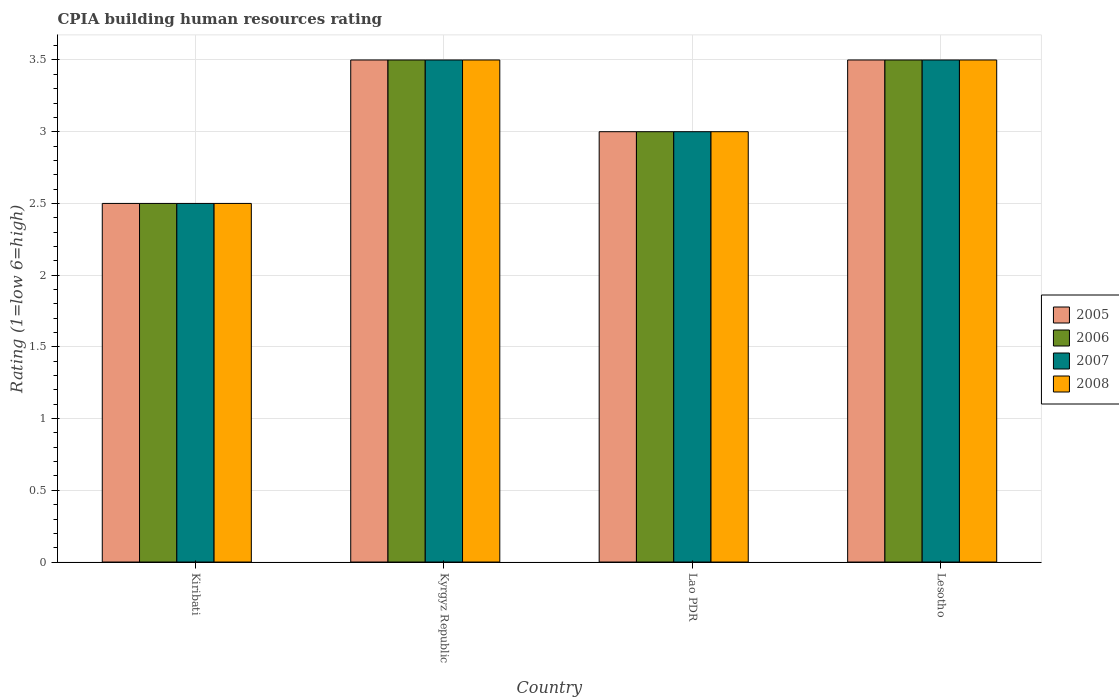Are the number of bars per tick equal to the number of legend labels?
Your answer should be very brief. Yes. Are the number of bars on each tick of the X-axis equal?
Give a very brief answer. Yes. How many bars are there on the 2nd tick from the left?
Ensure brevity in your answer.  4. What is the label of the 2nd group of bars from the left?
Provide a succinct answer. Kyrgyz Republic. In how many cases, is the number of bars for a given country not equal to the number of legend labels?
Give a very brief answer. 0. Across all countries, what is the maximum CPIA rating in 2007?
Offer a terse response. 3.5. In which country was the CPIA rating in 2008 maximum?
Make the answer very short. Kyrgyz Republic. In which country was the CPIA rating in 2006 minimum?
Your answer should be very brief. Kiribati. What is the total CPIA rating in 2008 in the graph?
Offer a terse response. 12.5. What is the average CPIA rating in 2007 per country?
Give a very brief answer. 3.12. What is the ratio of the CPIA rating in 2007 in Kiribati to that in Lao PDR?
Provide a short and direct response. 0.83. Is the difference between the CPIA rating in 2005 in Kiribati and Kyrgyz Republic greater than the difference between the CPIA rating in 2007 in Kiribati and Kyrgyz Republic?
Your answer should be very brief. No. What is the difference between the highest and the lowest CPIA rating in 2006?
Ensure brevity in your answer.  1. In how many countries, is the CPIA rating in 2007 greater than the average CPIA rating in 2007 taken over all countries?
Provide a short and direct response. 2. What does the 4th bar from the right in Lao PDR represents?
Make the answer very short. 2005. Is it the case that in every country, the sum of the CPIA rating in 2005 and CPIA rating in 2007 is greater than the CPIA rating in 2006?
Give a very brief answer. Yes. How many bars are there?
Give a very brief answer. 16. How many countries are there in the graph?
Offer a very short reply. 4. What is the difference between two consecutive major ticks on the Y-axis?
Offer a terse response. 0.5. Does the graph contain any zero values?
Give a very brief answer. No. Does the graph contain grids?
Your response must be concise. Yes. How many legend labels are there?
Your answer should be compact. 4. What is the title of the graph?
Offer a very short reply. CPIA building human resources rating. Does "1987" appear as one of the legend labels in the graph?
Provide a succinct answer. No. What is the label or title of the X-axis?
Give a very brief answer. Country. What is the label or title of the Y-axis?
Ensure brevity in your answer.  Rating (1=low 6=high). What is the Rating (1=low 6=high) in 2006 in Kiribati?
Your answer should be very brief. 2.5. What is the Rating (1=low 6=high) in 2007 in Kiribati?
Your answer should be compact. 2.5. What is the Rating (1=low 6=high) in 2008 in Kyrgyz Republic?
Your response must be concise. 3.5. What is the Rating (1=low 6=high) of 2007 in Lao PDR?
Keep it short and to the point. 3. What is the Rating (1=low 6=high) in 2007 in Lesotho?
Make the answer very short. 3.5. Across all countries, what is the maximum Rating (1=low 6=high) in 2006?
Ensure brevity in your answer.  3.5. Across all countries, what is the maximum Rating (1=low 6=high) of 2007?
Give a very brief answer. 3.5. Across all countries, what is the minimum Rating (1=low 6=high) of 2005?
Provide a short and direct response. 2.5. What is the total Rating (1=low 6=high) of 2006 in the graph?
Your answer should be very brief. 12.5. What is the total Rating (1=low 6=high) in 2007 in the graph?
Offer a very short reply. 12.5. What is the total Rating (1=low 6=high) in 2008 in the graph?
Keep it short and to the point. 12.5. What is the difference between the Rating (1=low 6=high) of 2006 in Kiribati and that in Kyrgyz Republic?
Your answer should be compact. -1. What is the difference between the Rating (1=low 6=high) in 2008 in Kiribati and that in Kyrgyz Republic?
Keep it short and to the point. -1. What is the difference between the Rating (1=low 6=high) of 2005 in Kiribati and that in Lao PDR?
Offer a very short reply. -0.5. What is the difference between the Rating (1=low 6=high) of 2006 in Kiribati and that in Lao PDR?
Ensure brevity in your answer.  -0.5. What is the difference between the Rating (1=low 6=high) of 2005 in Kiribati and that in Lesotho?
Keep it short and to the point. -1. What is the difference between the Rating (1=low 6=high) of 2006 in Kiribati and that in Lesotho?
Keep it short and to the point. -1. What is the difference between the Rating (1=low 6=high) in 2007 in Kiribati and that in Lesotho?
Your response must be concise. -1. What is the difference between the Rating (1=low 6=high) in 2008 in Kiribati and that in Lesotho?
Provide a short and direct response. -1. What is the difference between the Rating (1=low 6=high) of 2005 in Kyrgyz Republic and that in Lao PDR?
Offer a terse response. 0.5. What is the difference between the Rating (1=low 6=high) of 2007 in Kyrgyz Republic and that in Lao PDR?
Ensure brevity in your answer.  0.5. What is the difference between the Rating (1=low 6=high) in 2007 in Kyrgyz Republic and that in Lesotho?
Provide a succinct answer. 0. What is the difference between the Rating (1=low 6=high) in 2006 in Lao PDR and that in Lesotho?
Provide a succinct answer. -0.5. What is the difference between the Rating (1=low 6=high) in 2007 in Lao PDR and that in Lesotho?
Your response must be concise. -0.5. What is the difference between the Rating (1=low 6=high) of 2005 in Kiribati and the Rating (1=low 6=high) of 2007 in Kyrgyz Republic?
Make the answer very short. -1. What is the difference between the Rating (1=low 6=high) in 2005 in Kiribati and the Rating (1=low 6=high) in 2008 in Kyrgyz Republic?
Keep it short and to the point. -1. What is the difference between the Rating (1=low 6=high) of 2006 in Kiribati and the Rating (1=low 6=high) of 2007 in Kyrgyz Republic?
Offer a terse response. -1. What is the difference between the Rating (1=low 6=high) in 2006 in Kiribati and the Rating (1=low 6=high) in 2008 in Kyrgyz Republic?
Your response must be concise. -1. What is the difference between the Rating (1=low 6=high) of 2007 in Kiribati and the Rating (1=low 6=high) of 2008 in Kyrgyz Republic?
Give a very brief answer. -1. What is the difference between the Rating (1=low 6=high) in 2005 in Kiribati and the Rating (1=low 6=high) in 2006 in Lao PDR?
Your answer should be very brief. -0.5. What is the difference between the Rating (1=low 6=high) in 2005 in Kiribati and the Rating (1=low 6=high) in 2007 in Lao PDR?
Offer a very short reply. -0.5. What is the difference between the Rating (1=low 6=high) in 2006 in Kiribati and the Rating (1=low 6=high) in 2007 in Lao PDR?
Keep it short and to the point. -0.5. What is the difference between the Rating (1=low 6=high) in 2006 in Kiribati and the Rating (1=low 6=high) in 2008 in Lao PDR?
Your answer should be compact. -0.5. What is the difference between the Rating (1=low 6=high) of 2005 in Kiribati and the Rating (1=low 6=high) of 2006 in Lesotho?
Keep it short and to the point. -1. What is the difference between the Rating (1=low 6=high) in 2007 in Kiribati and the Rating (1=low 6=high) in 2008 in Lesotho?
Provide a succinct answer. -1. What is the difference between the Rating (1=low 6=high) of 2005 in Kyrgyz Republic and the Rating (1=low 6=high) of 2006 in Lao PDR?
Offer a terse response. 0.5. What is the difference between the Rating (1=low 6=high) in 2005 in Kyrgyz Republic and the Rating (1=low 6=high) in 2008 in Lao PDR?
Your answer should be very brief. 0.5. What is the difference between the Rating (1=low 6=high) in 2006 in Kyrgyz Republic and the Rating (1=low 6=high) in 2008 in Lao PDR?
Provide a short and direct response. 0.5. What is the difference between the Rating (1=low 6=high) of 2006 in Kyrgyz Republic and the Rating (1=low 6=high) of 2008 in Lesotho?
Provide a short and direct response. 0. What is the difference between the Rating (1=low 6=high) of 2007 in Kyrgyz Republic and the Rating (1=low 6=high) of 2008 in Lesotho?
Ensure brevity in your answer.  0. What is the difference between the Rating (1=low 6=high) of 2005 in Lao PDR and the Rating (1=low 6=high) of 2006 in Lesotho?
Provide a succinct answer. -0.5. What is the difference between the Rating (1=low 6=high) in 2006 in Lao PDR and the Rating (1=low 6=high) in 2007 in Lesotho?
Your response must be concise. -0.5. What is the difference between the Rating (1=low 6=high) of 2006 in Lao PDR and the Rating (1=low 6=high) of 2008 in Lesotho?
Offer a terse response. -0.5. What is the difference between the Rating (1=low 6=high) in 2007 in Lao PDR and the Rating (1=low 6=high) in 2008 in Lesotho?
Your answer should be very brief. -0.5. What is the average Rating (1=low 6=high) in 2005 per country?
Offer a terse response. 3.12. What is the average Rating (1=low 6=high) in 2006 per country?
Your answer should be compact. 3.12. What is the average Rating (1=low 6=high) of 2007 per country?
Offer a terse response. 3.12. What is the average Rating (1=low 6=high) in 2008 per country?
Ensure brevity in your answer.  3.12. What is the difference between the Rating (1=low 6=high) in 2005 and Rating (1=low 6=high) in 2006 in Kiribati?
Offer a terse response. 0. What is the difference between the Rating (1=low 6=high) of 2005 and Rating (1=low 6=high) of 2008 in Kiribati?
Make the answer very short. 0. What is the difference between the Rating (1=low 6=high) in 2006 and Rating (1=low 6=high) in 2007 in Kiribati?
Offer a very short reply. 0. What is the difference between the Rating (1=low 6=high) in 2007 and Rating (1=low 6=high) in 2008 in Kiribati?
Your response must be concise. 0. What is the difference between the Rating (1=low 6=high) of 2005 and Rating (1=low 6=high) of 2008 in Kyrgyz Republic?
Offer a terse response. 0. What is the difference between the Rating (1=low 6=high) of 2006 and Rating (1=low 6=high) of 2007 in Kyrgyz Republic?
Offer a very short reply. 0. What is the difference between the Rating (1=low 6=high) of 2007 and Rating (1=low 6=high) of 2008 in Kyrgyz Republic?
Provide a short and direct response. 0. What is the difference between the Rating (1=low 6=high) in 2005 and Rating (1=low 6=high) in 2006 in Lao PDR?
Provide a succinct answer. 0. What is the difference between the Rating (1=low 6=high) in 2005 and Rating (1=low 6=high) in 2008 in Lao PDR?
Your answer should be very brief. 0. What is the difference between the Rating (1=low 6=high) in 2006 and Rating (1=low 6=high) in 2008 in Lao PDR?
Ensure brevity in your answer.  0. What is the difference between the Rating (1=low 6=high) in 2005 and Rating (1=low 6=high) in 2006 in Lesotho?
Offer a terse response. 0. What is the difference between the Rating (1=low 6=high) of 2005 and Rating (1=low 6=high) of 2008 in Lesotho?
Make the answer very short. 0. What is the difference between the Rating (1=low 6=high) in 2006 and Rating (1=low 6=high) in 2007 in Lesotho?
Give a very brief answer. 0. What is the difference between the Rating (1=low 6=high) in 2007 and Rating (1=low 6=high) in 2008 in Lesotho?
Provide a short and direct response. 0. What is the ratio of the Rating (1=low 6=high) in 2008 in Kiribati to that in Kyrgyz Republic?
Offer a very short reply. 0.71. What is the ratio of the Rating (1=low 6=high) in 2007 in Kiribati to that in Lao PDR?
Make the answer very short. 0.83. What is the ratio of the Rating (1=low 6=high) in 2006 in Kiribati to that in Lesotho?
Ensure brevity in your answer.  0.71. What is the ratio of the Rating (1=low 6=high) in 2006 in Kyrgyz Republic to that in Lao PDR?
Make the answer very short. 1.17. What is the ratio of the Rating (1=low 6=high) in 2008 in Kyrgyz Republic to that in Lao PDR?
Offer a terse response. 1.17. What is the ratio of the Rating (1=low 6=high) of 2006 in Kyrgyz Republic to that in Lesotho?
Offer a very short reply. 1. What is the ratio of the Rating (1=low 6=high) of 2008 in Kyrgyz Republic to that in Lesotho?
Offer a very short reply. 1. What is the ratio of the Rating (1=low 6=high) of 2007 in Lao PDR to that in Lesotho?
Keep it short and to the point. 0.86. What is the difference between the highest and the second highest Rating (1=low 6=high) of 2006?
Provide a short and direct response. 0. What is the difference between the highest and the second highest Rating (1=low 6=high) in 2008?
Your answer should be compact. 0. What is the difference between the highest and the lowest Rating (1=low 6=high) of 2005?
Provide a succinct answer. 1. What is the difference between the highest and the lowest Rating (1=low 6=high) in 2006?
Your answer should be very brief. 1. What is the difference between the highest and the lowest Rating (1=low 6=high) of 2007?
Give a very brief answer. 1. 